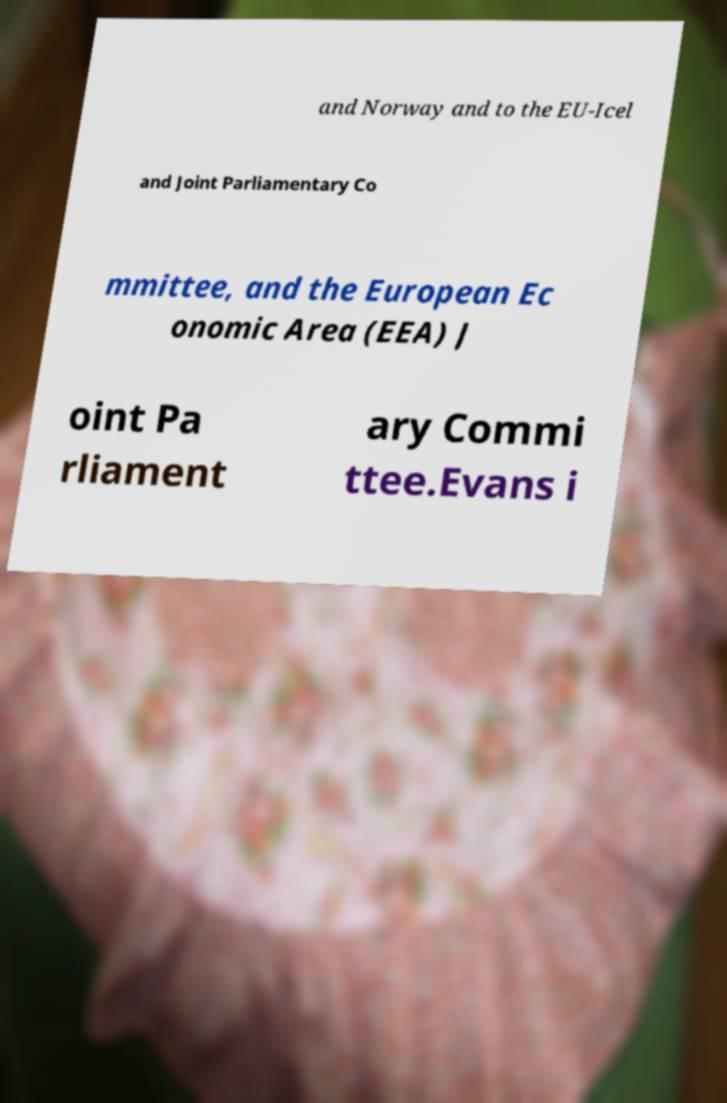Please identify and transcribe the text found in this image. and Norway and to the EU-Icel and Joint Parliamentary Co mmittee, and the European Ec onomic Area (EEA) J oint Pa rliament ary Commi ttee.Evans i 